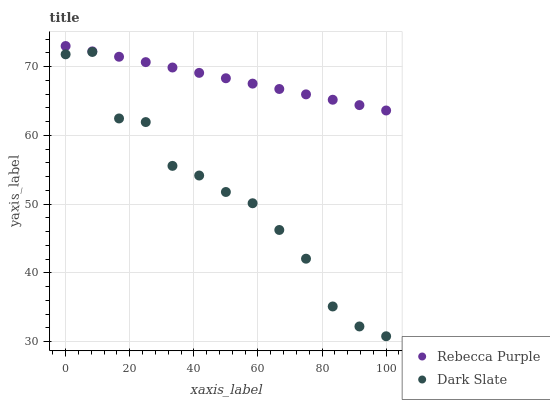Does Dark Slate have the minimum area under the curve?
Answer yes or no. Yes. Does Rebecca Purple have the maximum area under the curve?
Answer yes or no. Yes. Does Rebecca Purple have the minimum area under the curve?
Answer yes or no. No. Is Rebecca Purple the smoothest?
Answer yes or no. Yes. Is Dark Slate the roughest?
Answer yes or no. Yes. Is Rebecca Purple the roughest?
Answer yes or no. No. Does Dark Slate have the lowest value?
Answer yes or no. Yes. Does Rebecca Purple have the lowest value?
Answer yes or no. No. Does Rebecca Purple have the highest value?
Answer yes or no. Yes. Is Dark Slate less than Rebecca Purple?
Answer yes or no. Yes. Is Rebecca Purple greater than Dark Slate?
Answer yes or no. Yes. Does Dark Slate intersect Rebecca Purple?
Answer yes or no. No. 